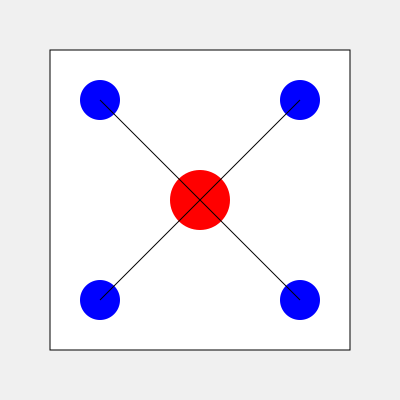Based on the dance floor diagram, where the red circle represents the DJ booth and blue circles represent speakers, predict the most likely crowd movement pattern during the peak of the night. Which area of the dance floor will likely have the highest density of dancers? To predict the crowd movement pattern and identify the area with the highest density of dancers, we need to consider several factors:

1. DJ booth location: The red circle in the center represents the DJ booth, which is typically a focal point for dancers.

2. Speaker placement: The blue circles in the corners represent speakers, which influence sound distribution and dancer positioning.

3. Sound waves: The curved lines emanating from the center represent sound waves, showing how sound travels across the dance floor.

4. Dance floor layout: The square represents the entire dance floor area.

Analyzing these elements:

1. Dancers tend to gravitate towards the DJ booth for visual connection and optimal sound.

2. The area directly in front of the DJ booth often has the best sound quality and visual experience.

3. Speakers in the corners create a surround sound effect, but the primary focus remains on the DJ booth.

4. The sound waves indicate that the area between the DJ booth and the front corners (bottom of the diagram) will have the best sound coverage.

5. Typically, dancers prefer to be closer to the DJ booth while maintaining some personal space.

Considering these factors, the area with the highest density of dancers is likely to be the space directly in front of the DJ booth, extending towards the front corners of the dance floor. This area provides the best combination of visual connection with the DJ, optimal sound quality, and ample space for movement.
Answer: Directly in front of the DJ booth, extending towards the front corners 